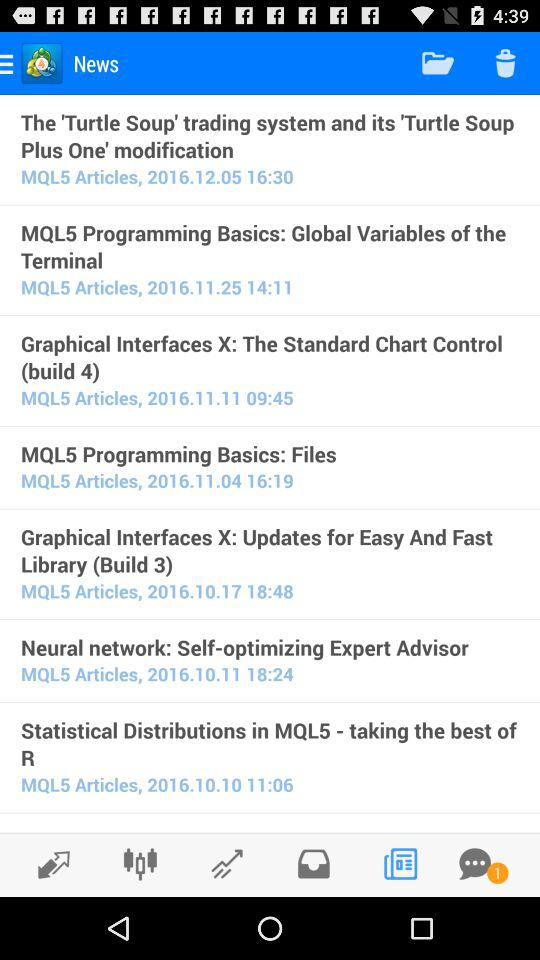Which news was published on 11.11.2016? The news that was published on November 11, 2016 is "Graphical Interfaces X: The Standard Chart Control (build 4)". 